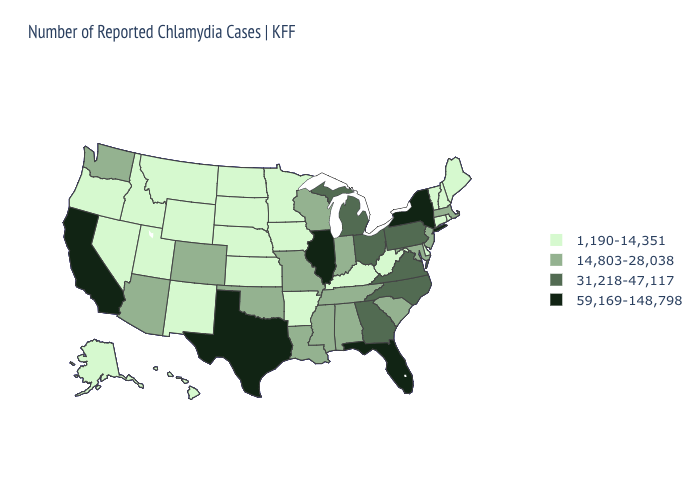Name the states that have a value in the range 31,218-47,117?
Concise answer only. Georgia, Michigan, North Carolina, Ohio, Pennsylvania, Virginia. What is the value of New Hampshire?
Keep it brief. 1,190-14,351. Does Minnesota have a lower value than Rhode Island?
Keep it brief. No. Which states have the lowest value in the USA?
Concise answer only. Alaska, Arkansas, Connecticut, Delaware, Hawaii, Idaho, Iowa, Kansas, Kentucky, Maine, Minnesota, Montana, Nebraska, Nevada, New Hampshire, New Mexico, North Dakota, Oregon, Rhode Island, South Dakota, Utah, Vermont, West Virginia, Wyoming. Does Connecticut have the lowest value in the USA?
Quick response, please. Yes. Name the states that have a value in the range 14,803-28,038?
Give a very brief answer. Alabama, Arizona, Colorado, Indiana, Louisiana, Maryland, Massachusetts, Mississippi, Missouri, New Jersey, Oklahoma, South Carolina, Tennessee, Washington, Wisconsin. Does the map have missing data?
Quick response, please. No. Which states have the highest value in the USA?
Give a very brief answer. California, Florida, Illinois, New York, Texas. What is the value of Ohio?
Write a very short answer. 31,218-47,117. What is the lowest value in the USA?
Answer briefly. 1,190-14,351. Name the states that have a value in the range 59,169-148,798?
Quick response, please. California, Florida, Illinois, New York, Texas. Does Virginia have the lowest value in the USA?
Give a very brief answer. No. Does Iowa have the same value as Washington?
Concise answer only. No. Does the first symbol in the legend represent the smallest category?
Write a very short answer. Yes. Does Alabama have a lower value than South Carolina?
Give a very brief answer. No. 